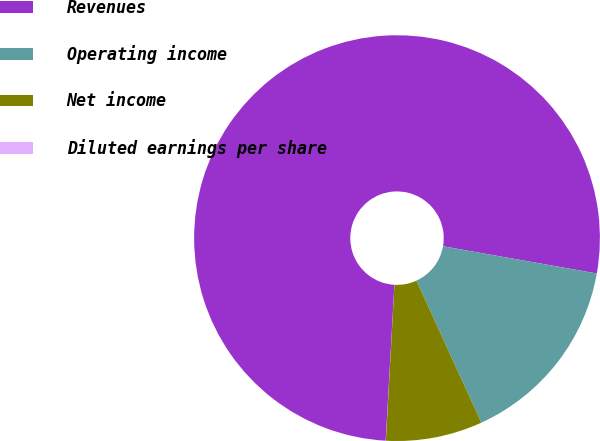Convert chart. <chart><loc_0><loc_0><loc_500><loc_500><pie_chart><fcel>Revenues<fcel>Operating income<fcel>Net income<fcel>Diluted earnings per share<nl><fcel>76.9%<fcel>15.39%<fcel>7.7%<fcel>0.01%<nl></chart> 